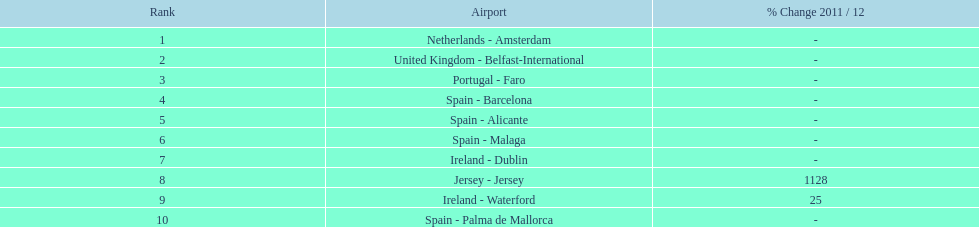What are all of the routes out of the london southend airport? Netherlands - Amsterdam, United Kingdom - Belfast-International, Portugal - Faro, Spain - Barcelona, Spain - Alicante, Spain - Malaga, Ireland - Dublin, Jersey - Jersey, Ireland - Waterford, Spain - Palma de Mallorca. How many passengers have traveled to each destination? 105,349, 92,502, 71,676, 66,565, 64,090, 59,175, 35,524, 35,169, 31,907, 27,718. And which destination has been the most popular to passengers? Netherlands - Amsterdam. 